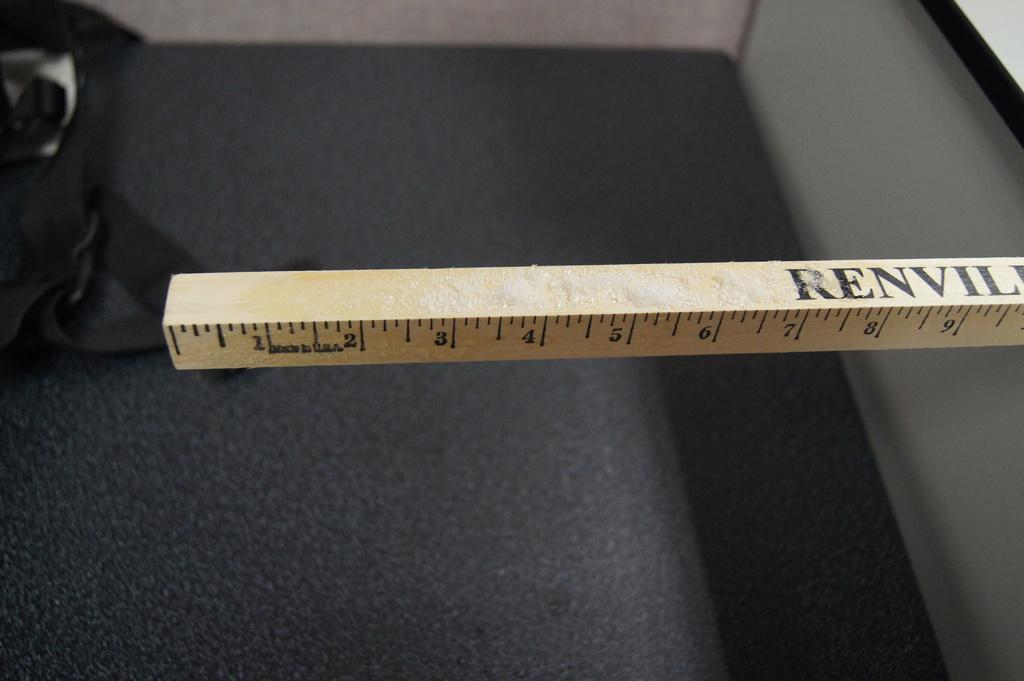<image>
Create a compact narrative representing the image presented. A brown ruler that is called renvil which is made in the USA. 